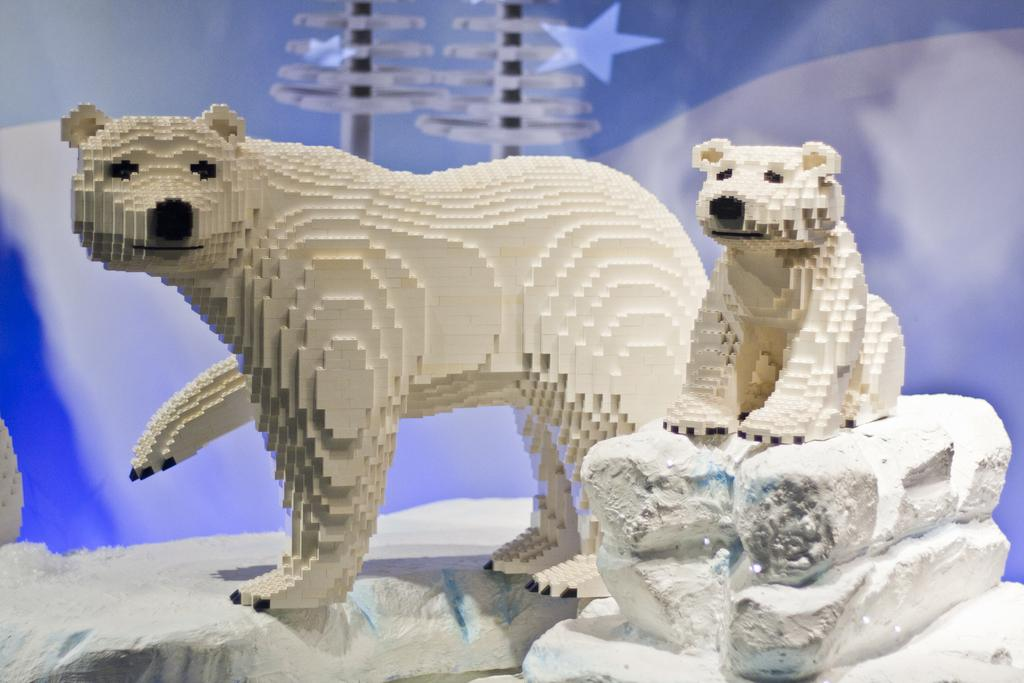What type of toys are featured in the image? There are toys made with legos in the image. What can be seen in the background of the image? There is a star and other objects in the background of the image. What is the color of the surface at the bottom of the image? The surface at the bottom of the image is white. What time does the brother's watch show in the image? There is no brother or watch present in the image. 